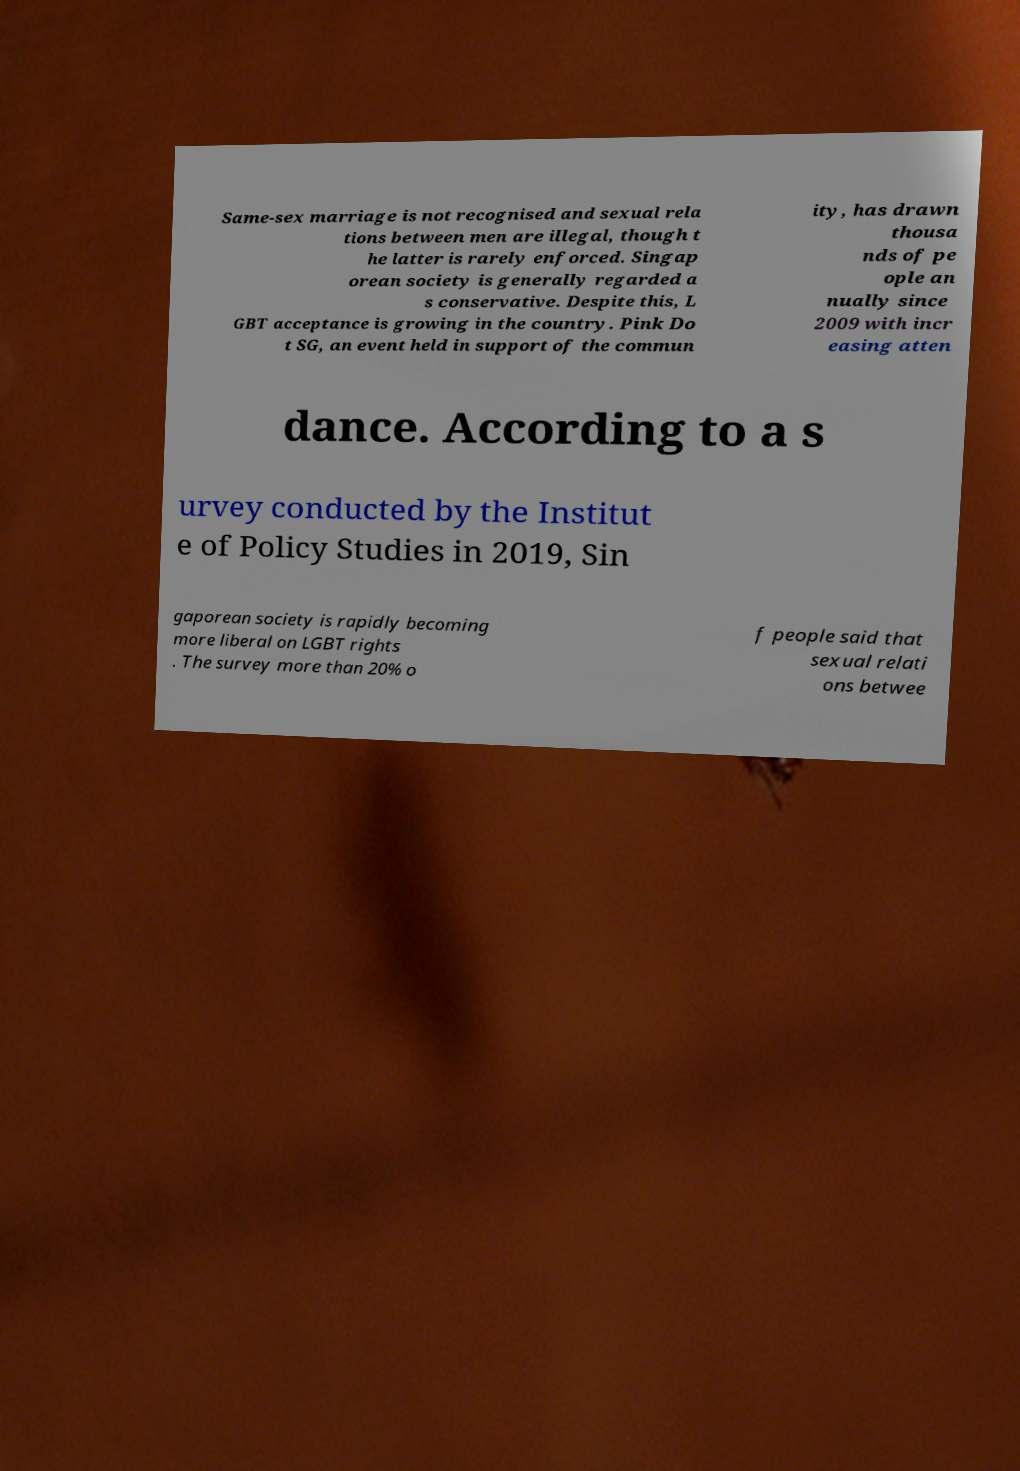I need the written content from this picture converted into text. Can you do that? Same-sex marriage is not recognised and sexual rela tions between men are illegal, though t he latter is rarely enforced. Singap orean society is generally regarded a s conservative. Despite this, L GBT acceptance is growing in the country. Pink Do t SG, an event held in support of the commun ity, has drawn thousa nds of pe ople an nually since 2009 with incr easing atten dance. According to a s urvey conducted by the Institut e of Policy Studies in 2019, Sin gaporean society is rapidly becoming more liberal on LGBT rights . The survey more than 20% o f people said that sexual relati ons betwee 